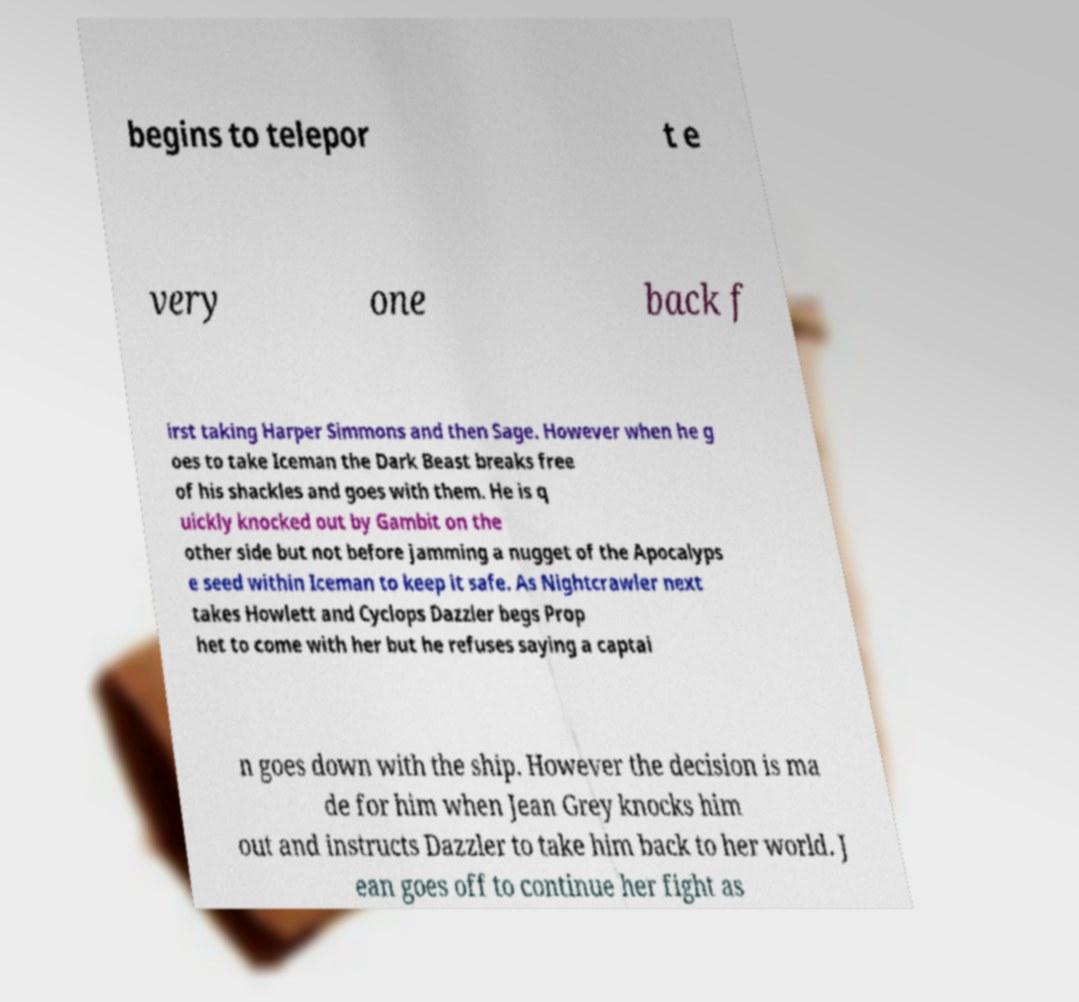Can you accurately transcribe the text from the provided image for me? begins to telepor t e very one back f irst taking Harper Simmons and then Sage. However when he g oes to take Iceman the Dark Beast breaks free of his shackles and goes with them. He is q uickly knocked out by Gambit on the other side but not before jamming a nugget of the Apocalyps e seed within Iceman to keep it safe. As Nightcrawler next takes Howlett and Cyclops Dazzler begs Prop het to come with her but he refuses saying a captai n goes down with the ship. However the decision is ma de for him when Jean Grey knocks him out and instructs Dazzler to take him back to her world. J ean goes off to continue her fight as 